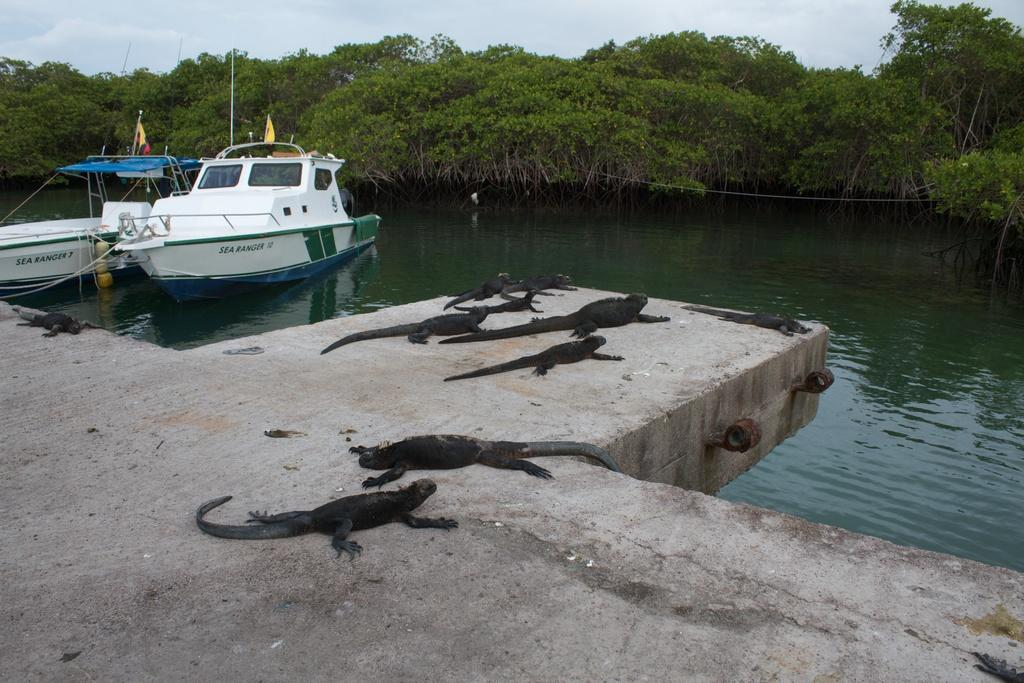How many boats can be seen in the water in the image? There are two boats in the water in the image. What can be seen in the background of the image? There are trees in the background of the image. What is present on the floor at the bottom of the image? There are small crocodiles on the floor at the bottom of the image. What is visible at the top of the image? The sky is visible at the top of the image. What type of nest can be seen in the image? There is no nest present in the image. 